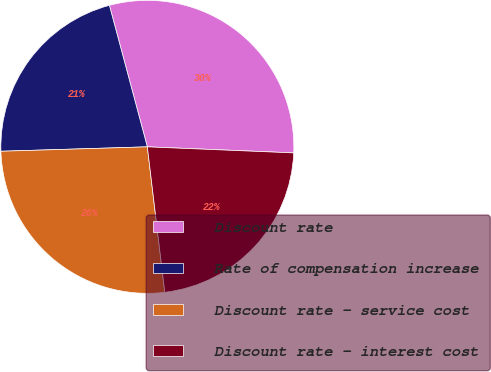Convert chart to OTSL. <chart><loc_0><loc_0><loc_500><loc_500><pie_chart><fcel>Discount rate<fcel>Rate of compensation increase<fcel>Discount rate - service cost<fcel>Discount rate - interest cost<nl><fcel>29.83%<fcel>21.31%<fcel>26.42%<fcel>22.44%<nl></chart> 